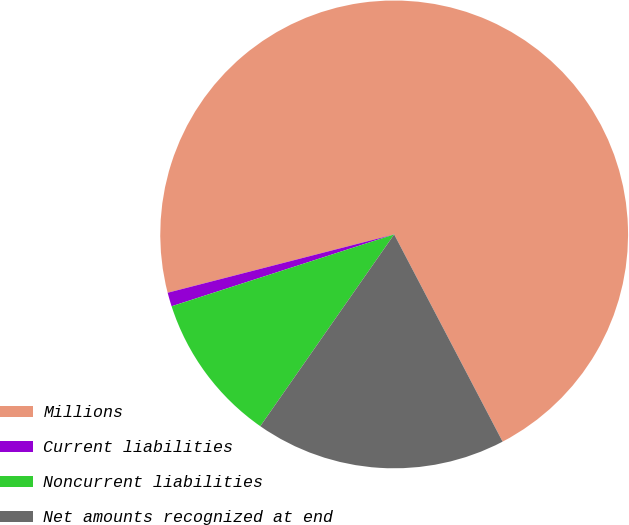Convert chart. <chart><loc_0><loc_0><loc_500><loc_500><pie_chart><fcel>Millions<fcel>Current liabilities<fcel>Noncurrent liabilities<fcel>Net amounts recognized at end<nl><fcel>71.34%<fcel>0.96%<fcel>10.33%<fcel>17.37%<nl></chart> 